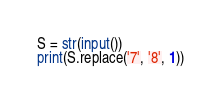Convert code to text. <code><loc_0><loc_0><loc_500><loc_500><_Python_>S = str(input())
print(S.replace('7', '8', 1))</code> 